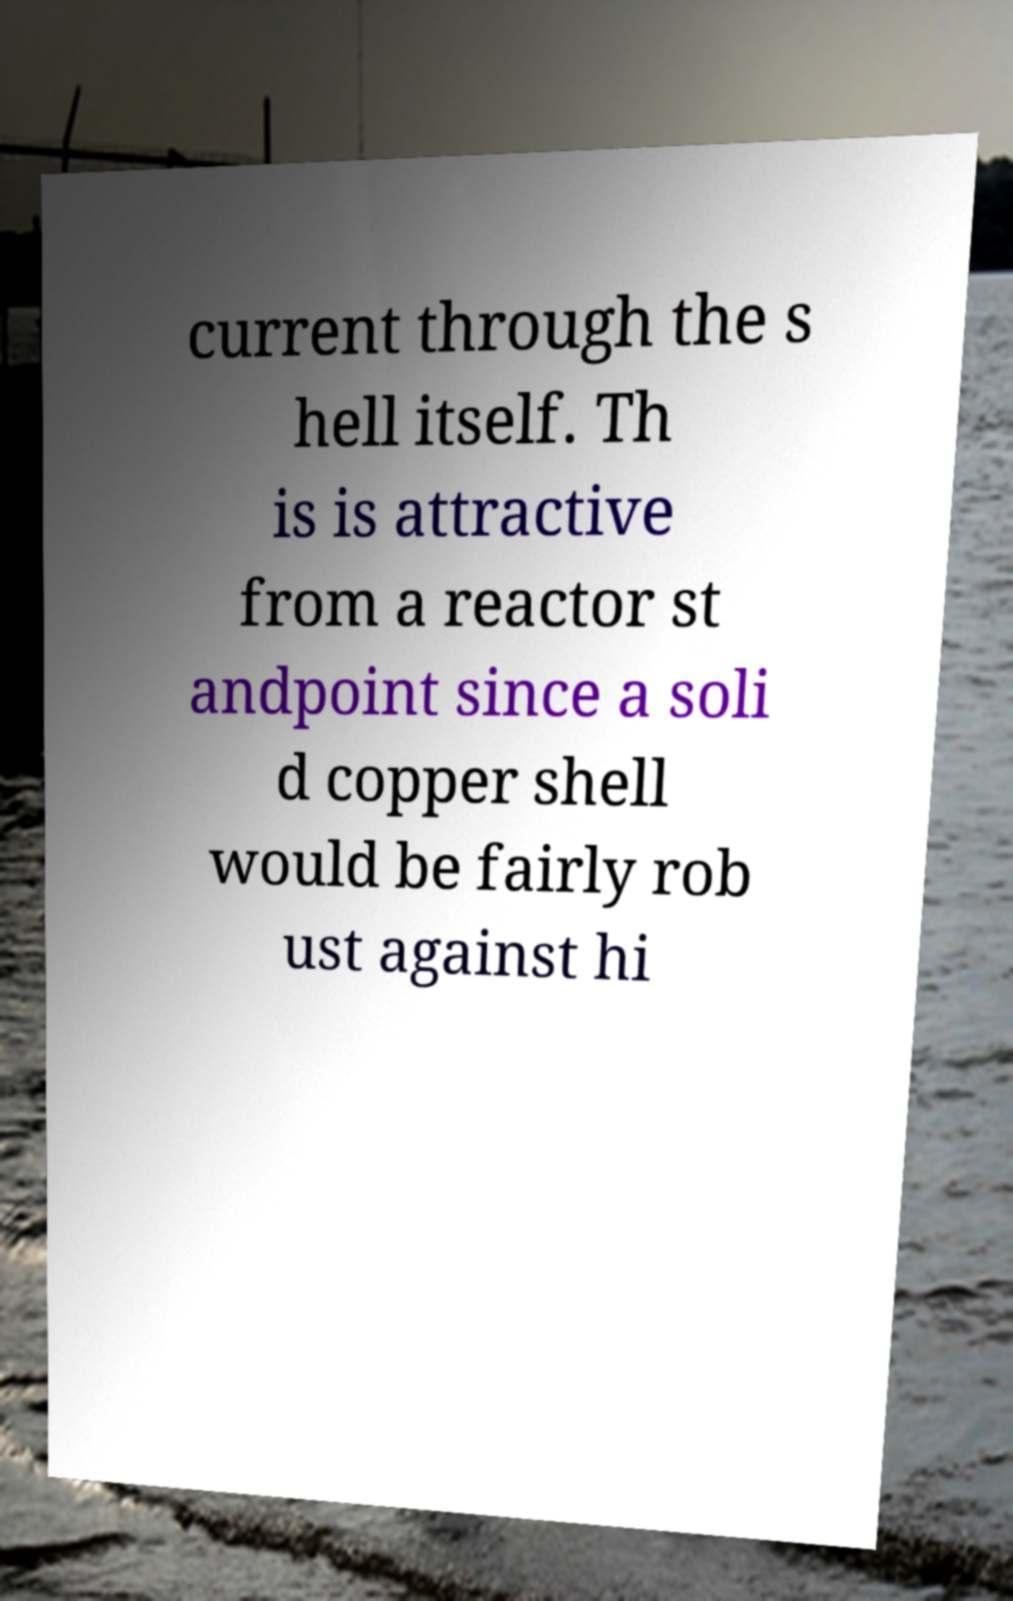I need the written content from this picture converted into text. Can you do that? current through the s hell itself. Th is is attractive from a reactor st andpoint since a soli d copper shell would be fairly rob ust against hi 